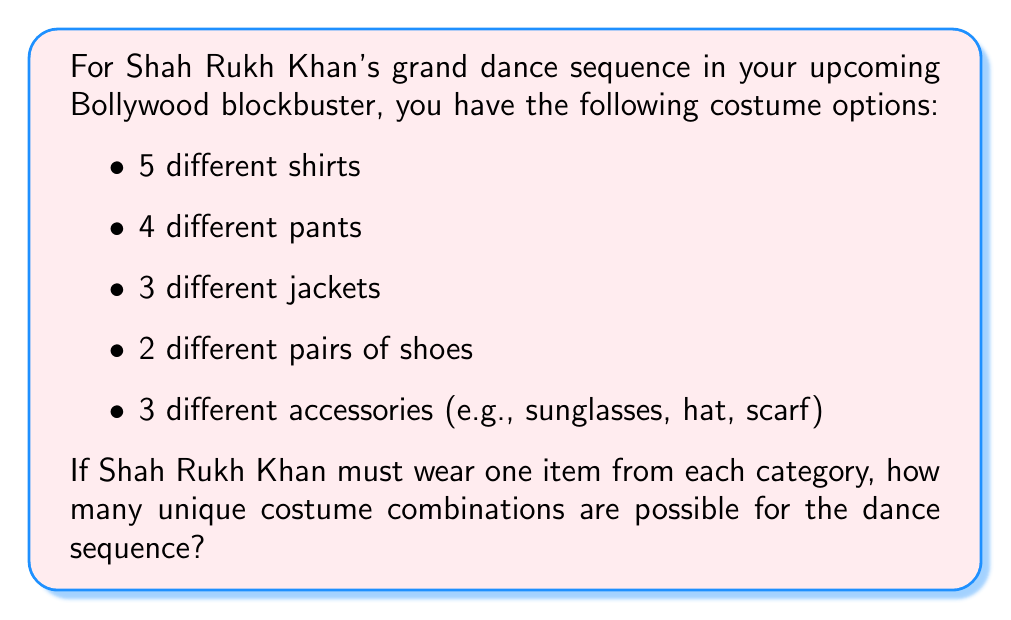Solve this math problem. To solve this problem, we'll use the multiplication principle of counting. This principle states that if we have a series of independent choices, the total number of possible outcomes is the product of the number of possibilities for each choice.

Let's break it down step-by-step:

1. Shirts: There are 5 options
2. Pants: There are 4 options
3. Jackets: There are 3 options
4. Shoes: There are 2 options
5. Accessories: There are 3 options

Since Shah Rukh Khan must choose one item from each category, and the choices are independent of each other, we multiply the number of options for each category:

$$\text{Total combinations} = 5 \times 4 \times 3 \times 2 \times 3$$

Calculating this:
$$\text{Total combinations} = 360$$

Therefore, there are 360 unique costume combinations possible for Shah Rukh Khan's dance sequence.
Answer: 360 